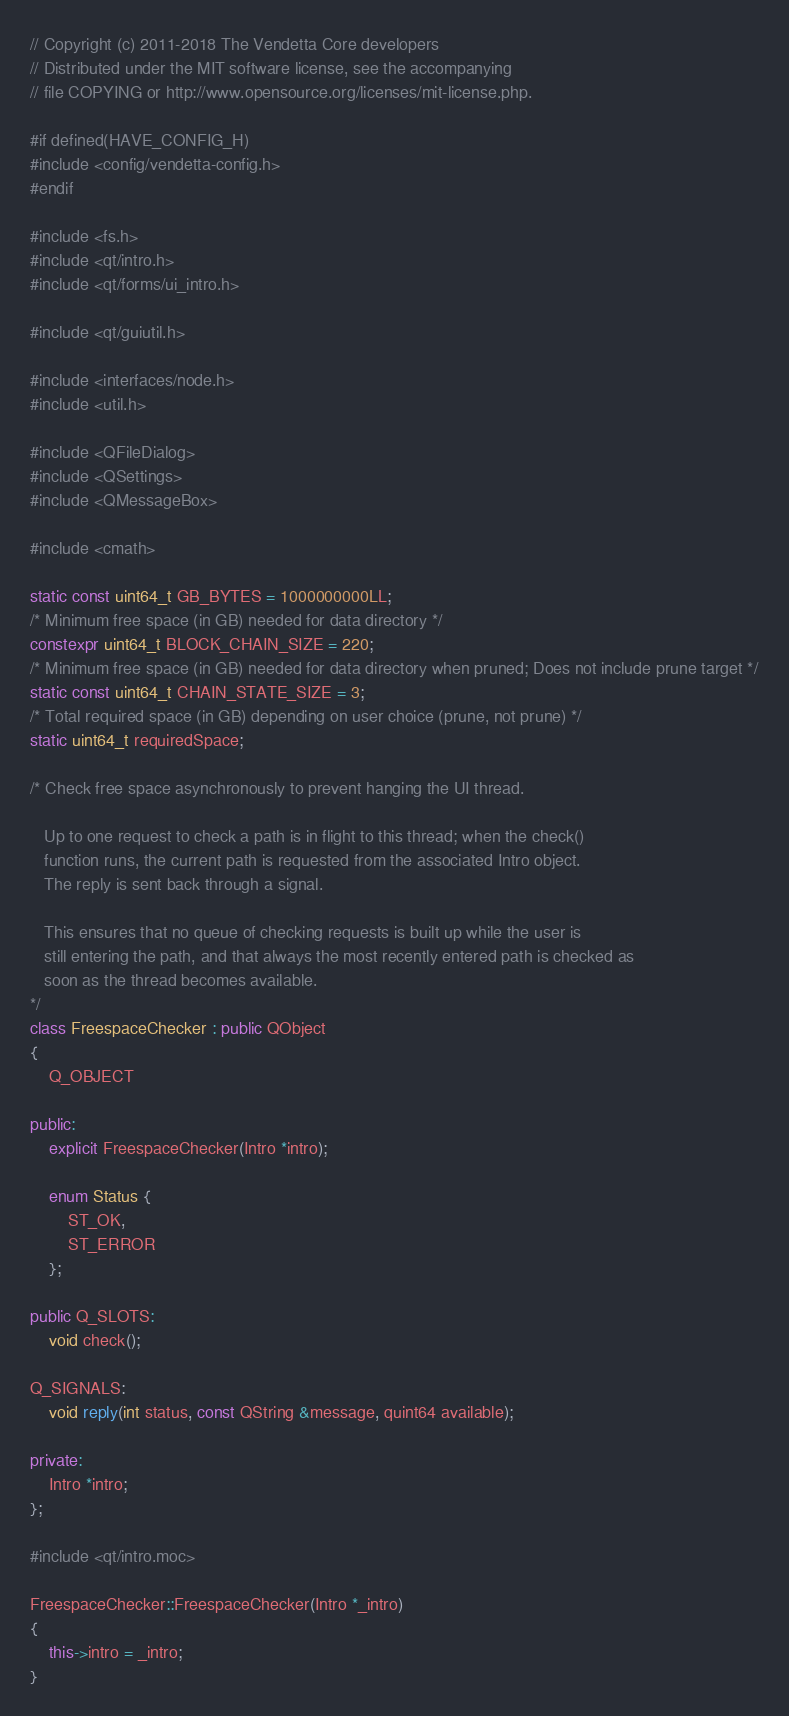<code> <loc_0><loc_0><loc_500><loc_500><_C++_>// Copyright (c) 2011-2018 The Vendetta Core developers
// Distributed under the MIT software license, see the accompanying
// file COPYING or http://www.opensource.org/licenses/mit-license.php.

#if defined(HAVE_CONFIG_H)
#include <config/vendetta-config.h>
#endif

#include <fs.h>
#include <qt/intro.h>
#include <qt/forms/ui_intro.h>

#include <qt/guiutil.h>

#include <interfaces/node.h>
#include <util.h>

#include <QFileDialog>
#include <QSettings>
#include <QMessageBox>

#include <cmath>

static const uint64_t GB_BYTES = 1000000000LL;
/* Minimum free space (in GB) needed for data directory */
constexpr uint64_t BLOCK_CHAIN_SIZE = 220;
/* Minimum free space (in GB) needed for data directory when pruned; Does not include prune target */
static const uint64_t CHAIN_STATE_SIZE = 3;
/* Total required space (in GB) depending on user choice (prune, not prune) */
static uint64_t requiredSpace;

/* Check free space asynchronously to prevent hanging the UI thread.

   Up to one request to check a path is in flight to this thread; when the check()
   function runs, the current path is requested from the associated Intro object.
   The reply is sent back through a signal.

   This ensures that no queue of checking requests is built up while the user is
   still entering the path, and that always the most recently entered path is checked as
   soon as the thread becomes available.
*/
class FreespaceChecker : public QObject
{
    Q_OBJECT

public:
    explicit FreespaceChecker(Intro *intro);

    enum Status {
        ST_OK,
        ST_ERROR
    };

public Q_SLOTS:
    void check();

Q_SIGNALS:
    void reply(int status, const QString &message, quint64 available);

private:
    Intro *intro;
};

#include <qt/intro.moc>

FreespaceChecker::FreespaceChecker(Intro *_intro)
{
    this->intro = _intro;
}
</code> 